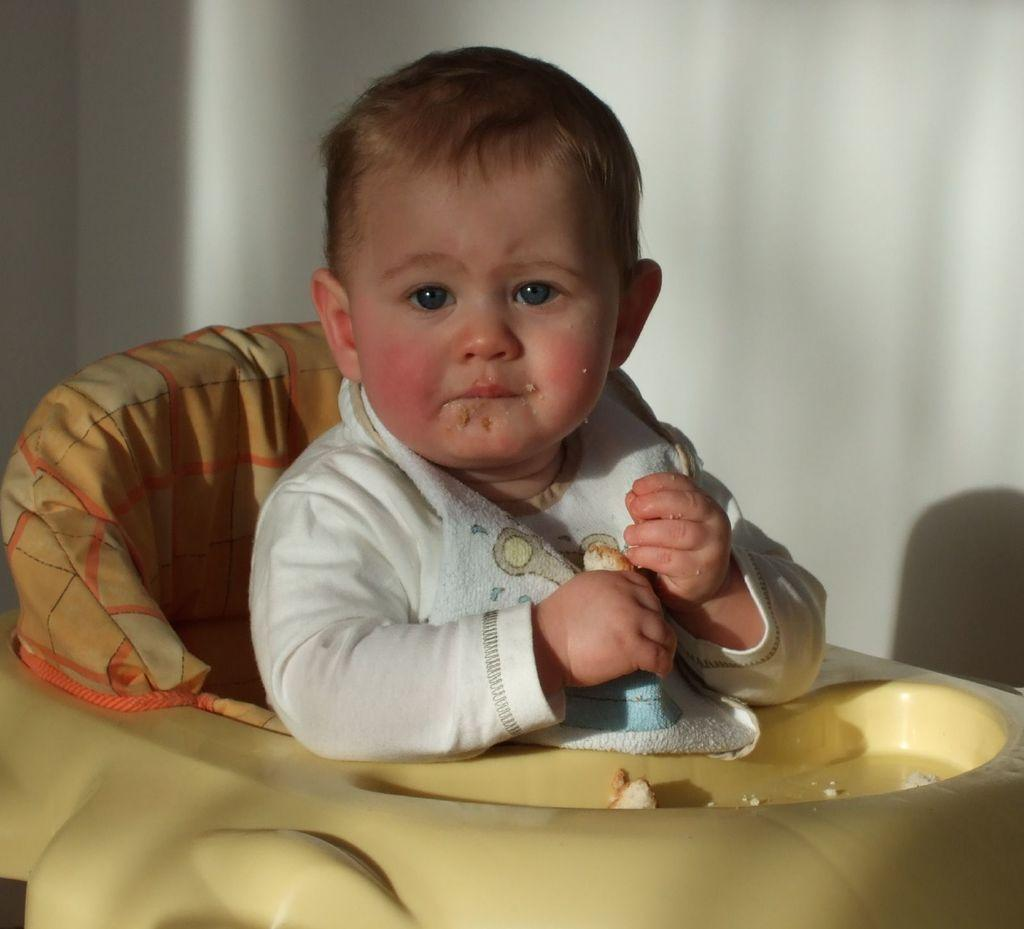What is the main subject of the image? The main subject of the image is a kid. What is the kid doing in the image? The kid is sitting on a chair. What can be seen in the background of the image? There is a wall in the background of the image. How many giants can be seen in the image? There are no giants present in the image. What type of crack is visible on the kid's mouth in the image? There is no crack visible on the kid's mouth in the image. 